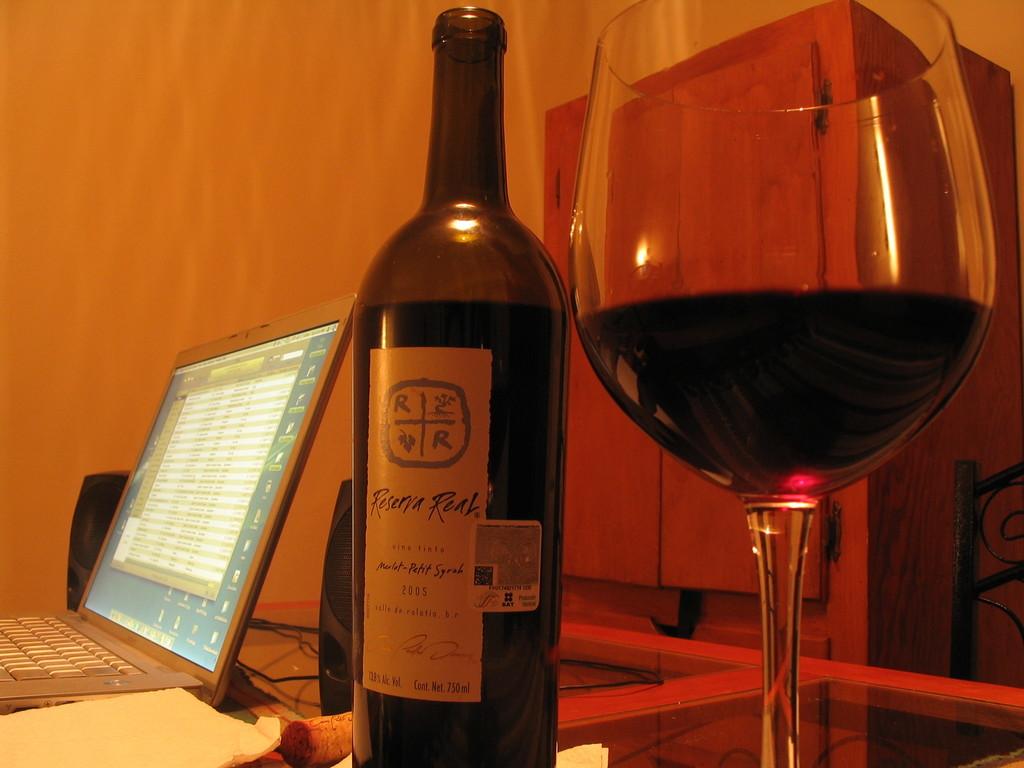What is the year on the bottle?
Provide a short and direct response. 2005. 